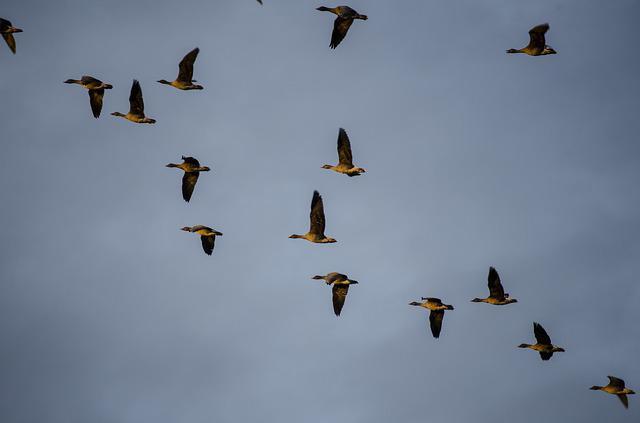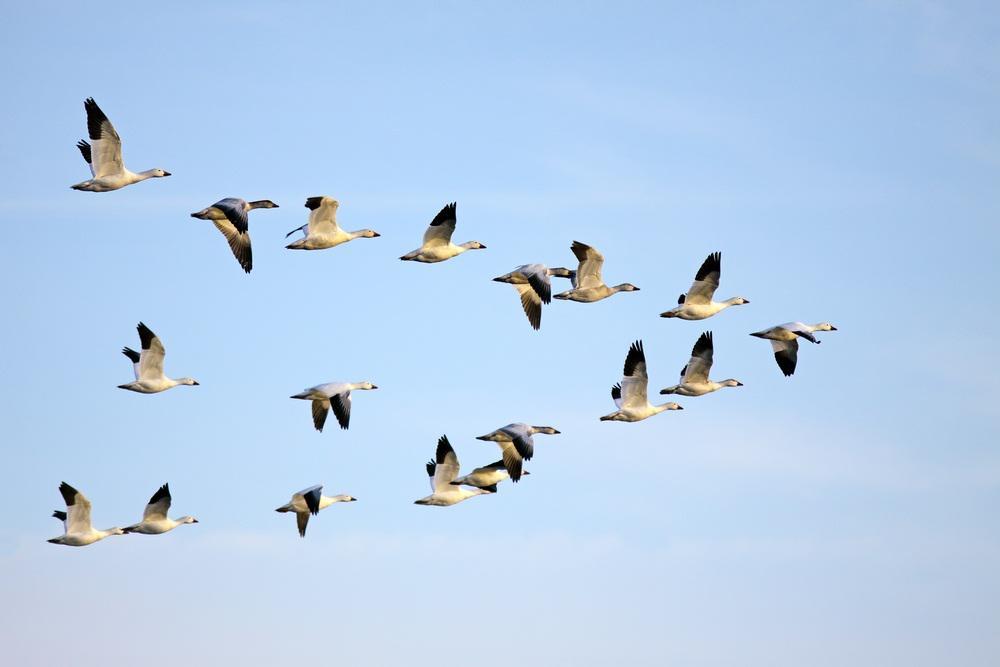The first image is the image on the left, the second image is the image on the right. Assess this claim about the two images: "The birds in the image on the right are flying in a v formation.". Correct or not? Answer yes or no. Yes. The first image is the image on the left, the second image is the image on the right. Evaluate the accuracy of this statement regarding the images: "There are many more than 40 birds in total.". Is it true? Answer yes or no. No. 